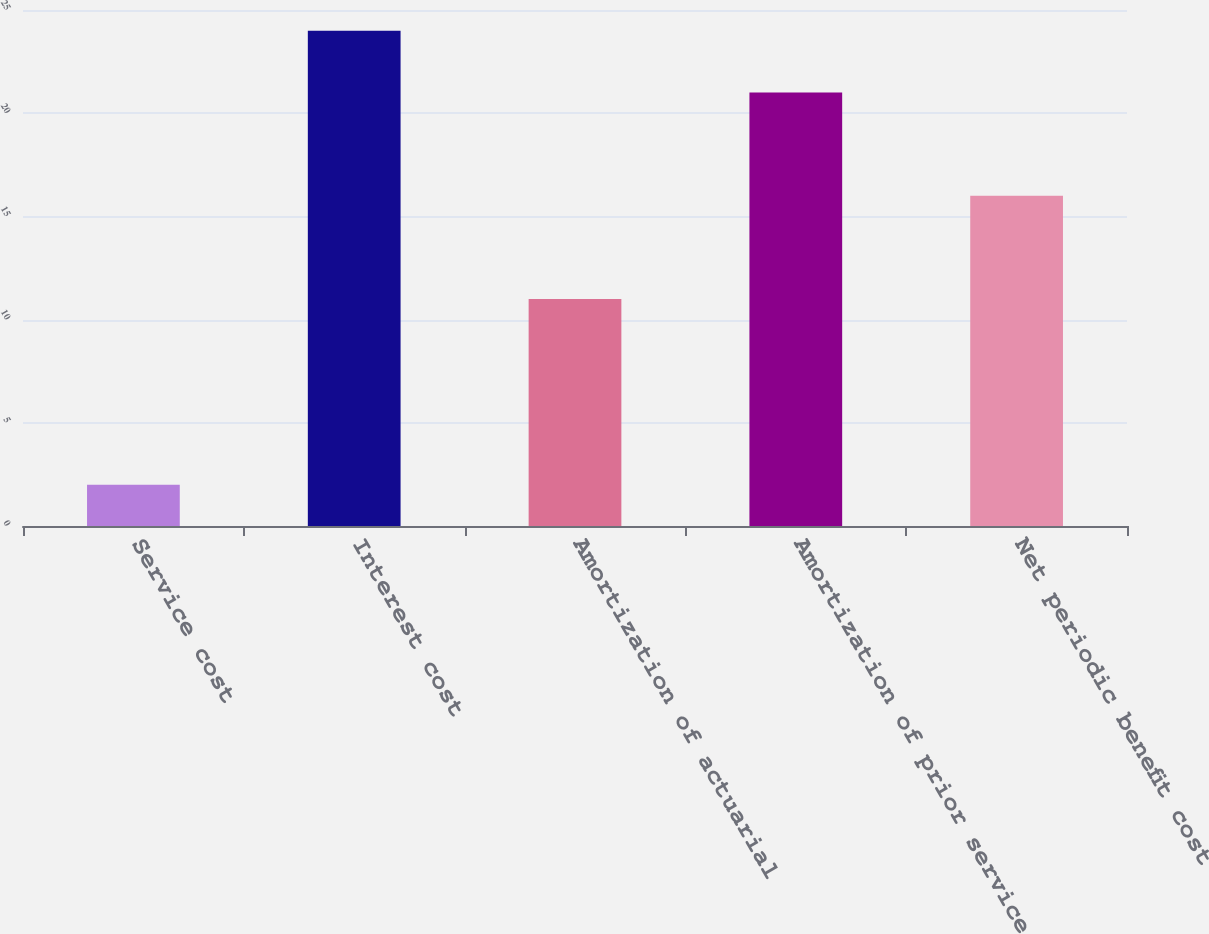Convert chart. <chart><loc_0><loc_0><loc_500><loc_500><bar_chart><fcel>Service cost<fcel>Interest cost<fcel>Amortization of actuarial<fcel>Amortization of prior service<fcel>Net periodic benefit cost<nl><fcel>2<fcel>24<fcel>11<fcel>21<fcel>16<nl></chart> 